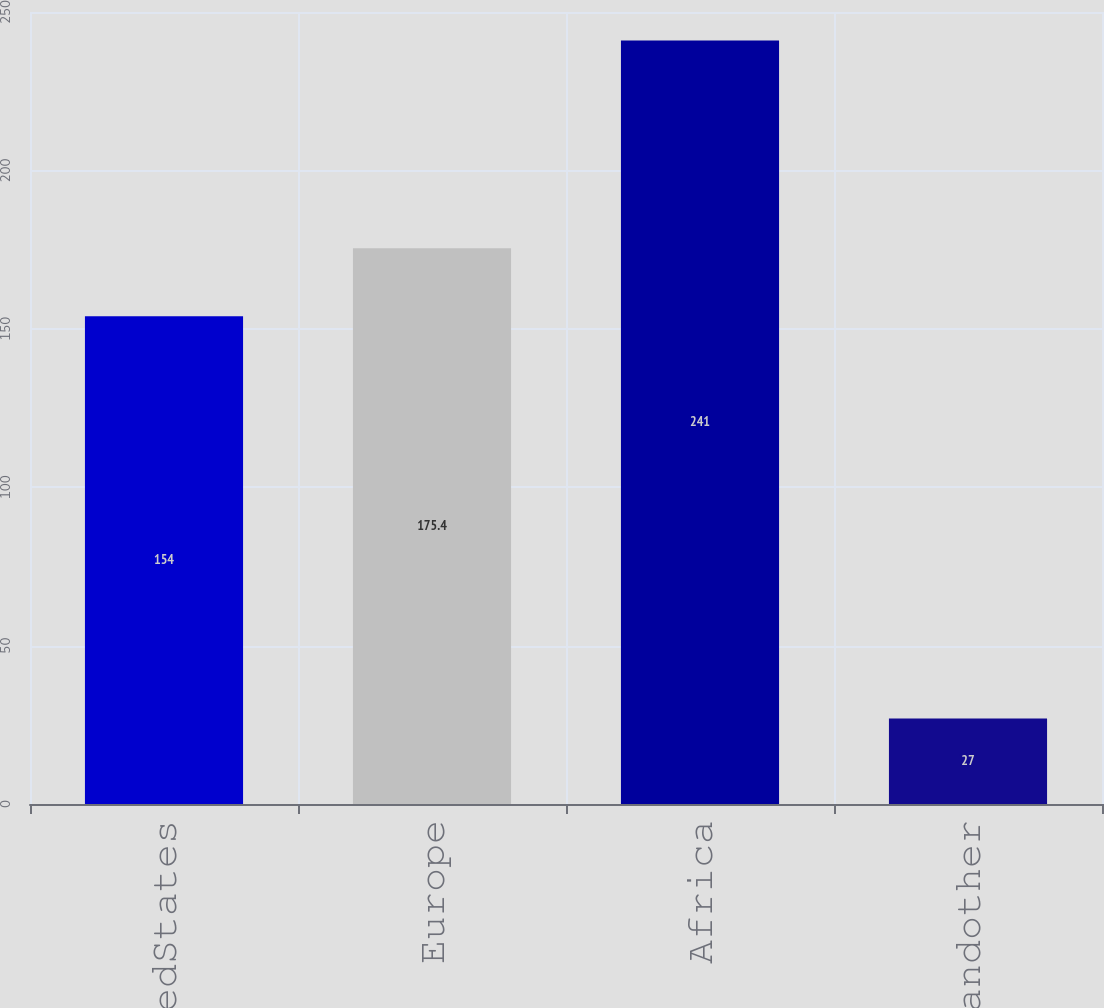Convert chart to OTSL. <chart><loc_0><loc_0><loc_500><loc_500><bar_chart><fcel>UnitedStates<fcel>Europe<fcel>Africa<fcel>Asiaandother<nl><fcel>154<fcel>175.4<fcel>241<fcel>27<nl></chart> 